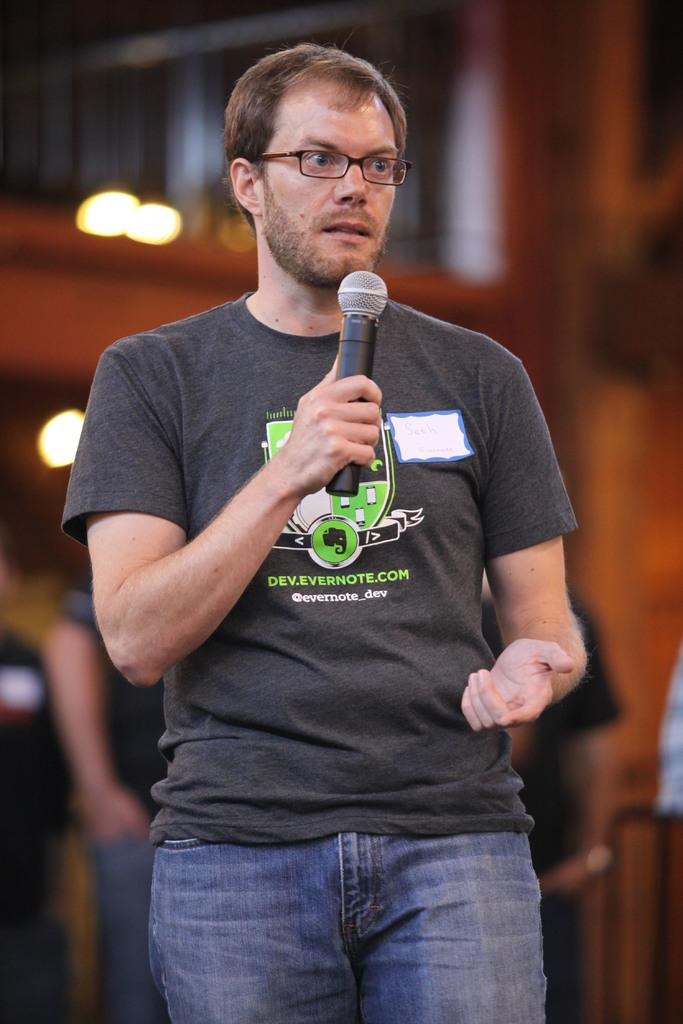What is the main subject of the image? The main subject of the image is a man. What is the man doing in the image? The man is standing in the image. What is the man wearing? The man is wearing clothes and spectacles. What object is the man holding in his hand? The man is holding a microphone in his hand. Can you describe the background of the image? The background of the image is blurred. What type of food is the man cooking in the image? There is no indication in the image that the man is cooking food, as he is holding a microphone and not interacting with any cooking equipment. 